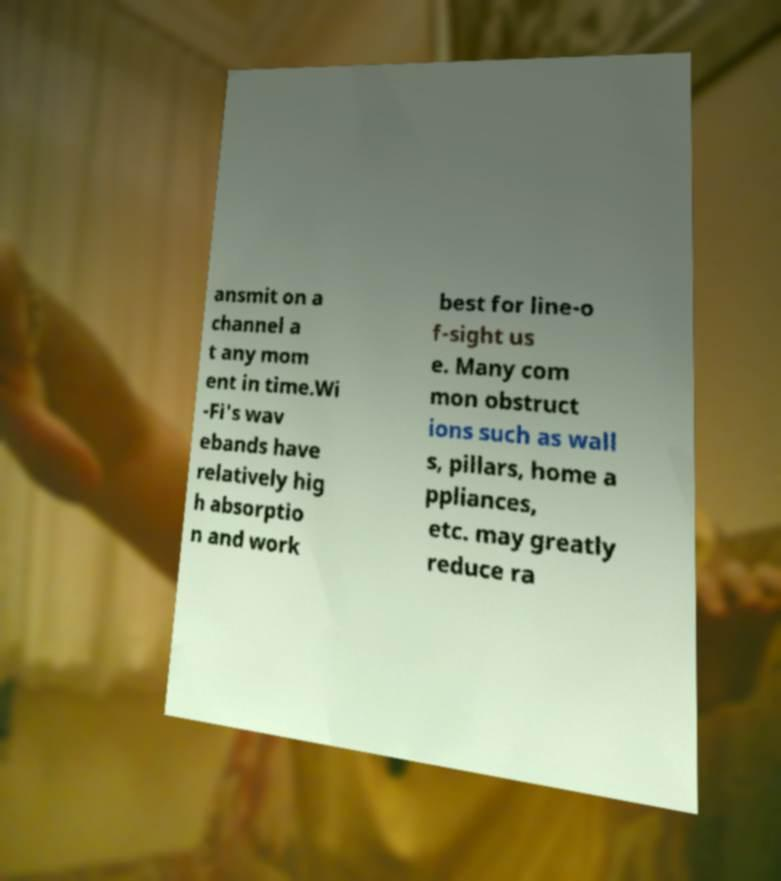There's text embedded in this image that I need extracted. Can you transcribe it verbatim? ansmit on a channel a t any mom ent in time.Wi -Fi's wav ebands have relatively hig h absorptio n and work best for line-o f-sight us e. Many com mon obstruct ions such as wall s, pillars, home a ppliances, etc. may greatly reduce ra 